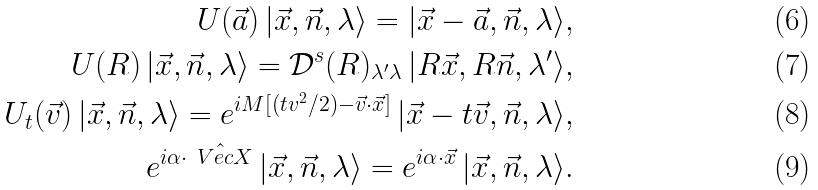Convert formula to latex. <formula><loc_0><loc_0><loc_500><loc_500>U ( \vec { a } ) \, | \vec { x } , \vec { n } , \lambda \rangle = | \vec { x } - \vec { a } , \vec { n } , \lambda \rangle , \\ U ( R ) \, | \vec { x } , \vec { n } , \lambda \rangle = { \mathcal { D } } ^ { s } ( R ) _ { \lambda ^ { \prime } \lambda } \, | R \vec { x } , R \vec { n } , \lambda ^ { \prime } \rangle , \\ U _ { t } ( \vec { v } ) \, | \vec { x } , \vec { n } , \lambda \rangle = e ^ { i M [ ( t v ^ { 2 } / 2 ) - \vec { v } \cdot \vec { x } ] } \, | \vec { x } - t \vec { v } , \vec { n } , \lambda \rangle , \\ e ^ { i \alpha \cdot \hat { \ V e c { X } } } \, | \vec { x } , \vec { n } , \lambda \rangle = e ^ { i \alpha \cdot \vec { x } } \, | \vec { x } , \vec { n } , \lambda \rangle .</formula> 